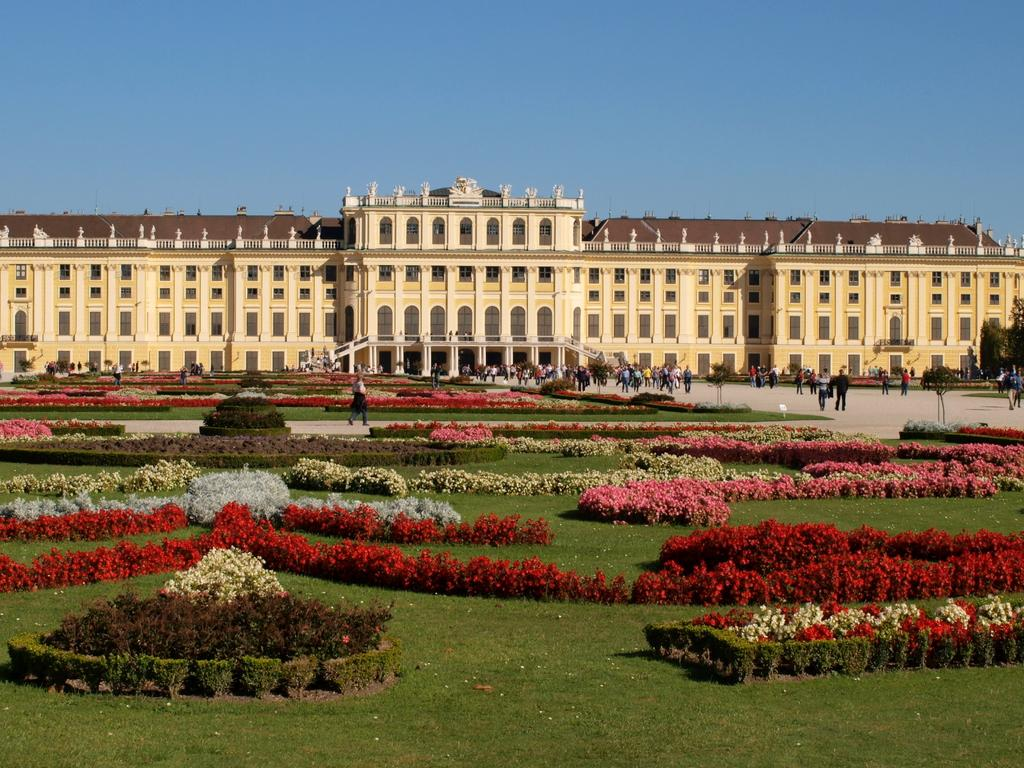What type of structure is present in the image? There is a building in the image. What else can be seen in the image besides the building? There is a group of people standing on the ground and a garden in the image. What is in the garden? The garden contains plants and grass. What can be seen in the background of the image? The sky is visible in the background of the image. What songs are being sung by the plants in the garden? There are no songs being sung by the plants in the garden, as plants do not have the ability to sing. 